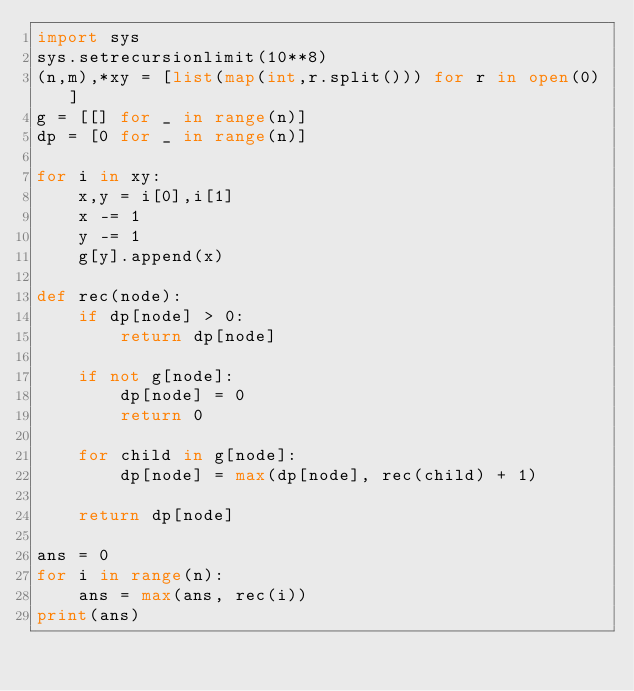Convert code to text. <code><loc_0><loc_0><loc_500><loc_500><_Python_>import sys
sys.setrecursionlimit(10**8)
(n,m),*xy = [list(map(int,r.split())) for r in open(0)]
g = [[] for _ in range(n)]
dp = [0 for _ in range(n)]

for i in xy:
    x,y = i[0],i[1]
    x -= 1
    y -= 1
    g[y].append(x)

def rec(node):
    if dp[node] > 0:
        return dp[node]
    
    if not g[node]:
        dp[node] = 0
        return 0

    for child in g[node]:
        dp[node] = max(dp[node], rec(child) + 1)

    return dp[node]

ans = 0
for i in range(n):
    ans = max(ans, rec(i))
print(ans)
</code> 